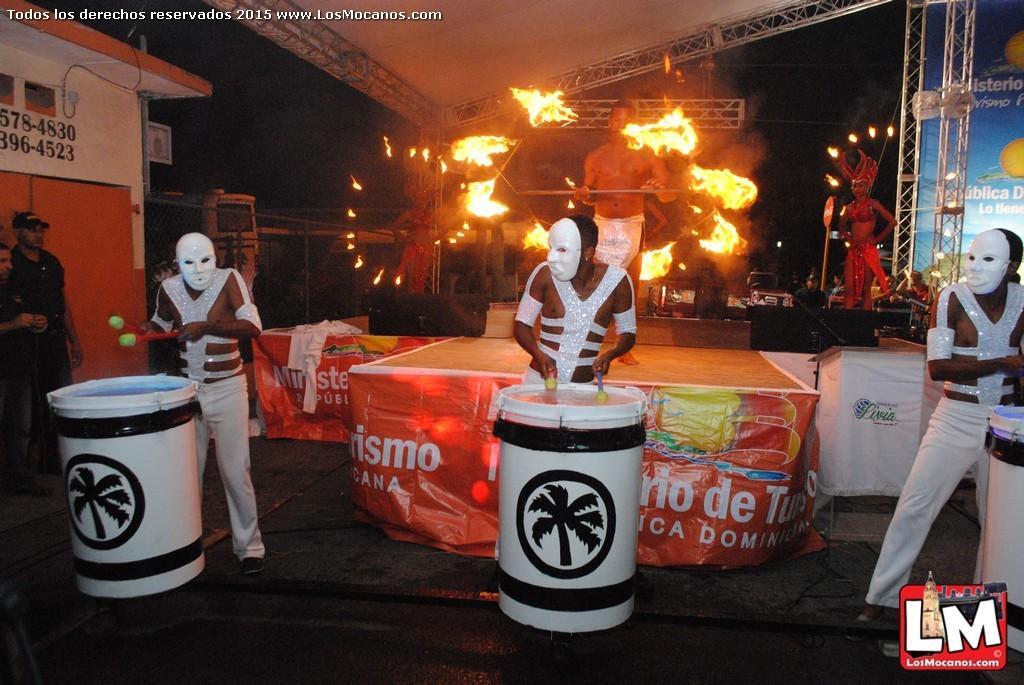Describe this image in one or two sentences. In the foreground of this image, there are three men playing drums holding drum sticks. On the left, there are two persons standing. In the background there is a man and two women holding fire sticks on the stage. On the right, there is a banner. On the top, there is the ceiling of the shelter and the dark sky. 